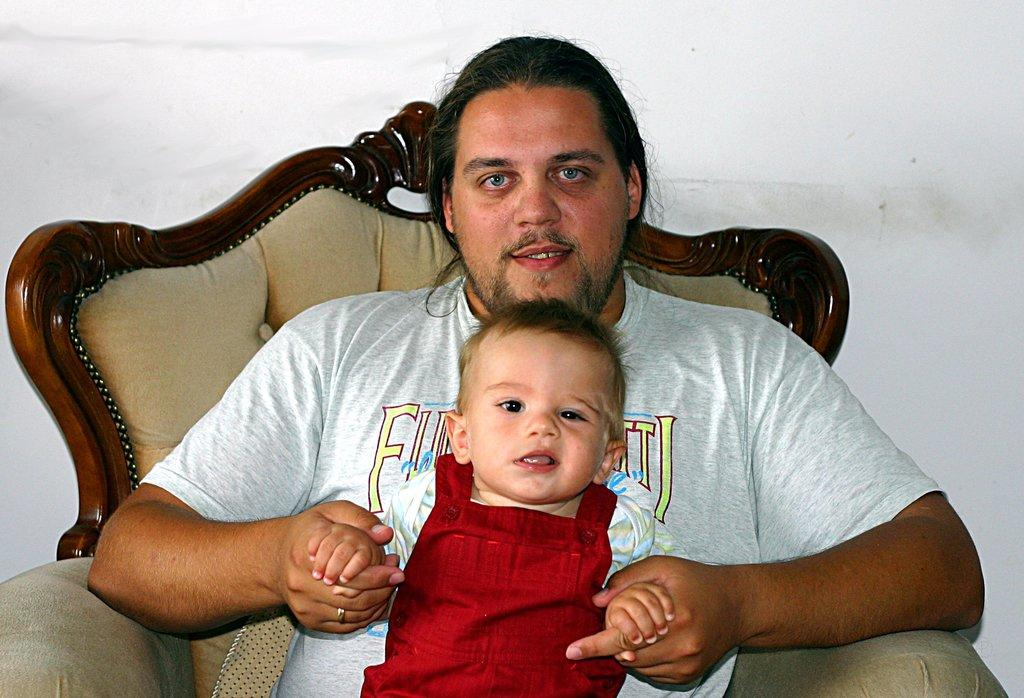What is the person in the image doing? The person is holding a baby in the image. What is the person's position in the image? The person is sitting on a chair. What is the baby wearing? The baby is wearing a red and white color dress. What color is the background of the image? The background of the image is white. What route is the person taking with the baby in the image? There is no indication of a route or movement in the image; the person is sitting on a chair holding the baby. 